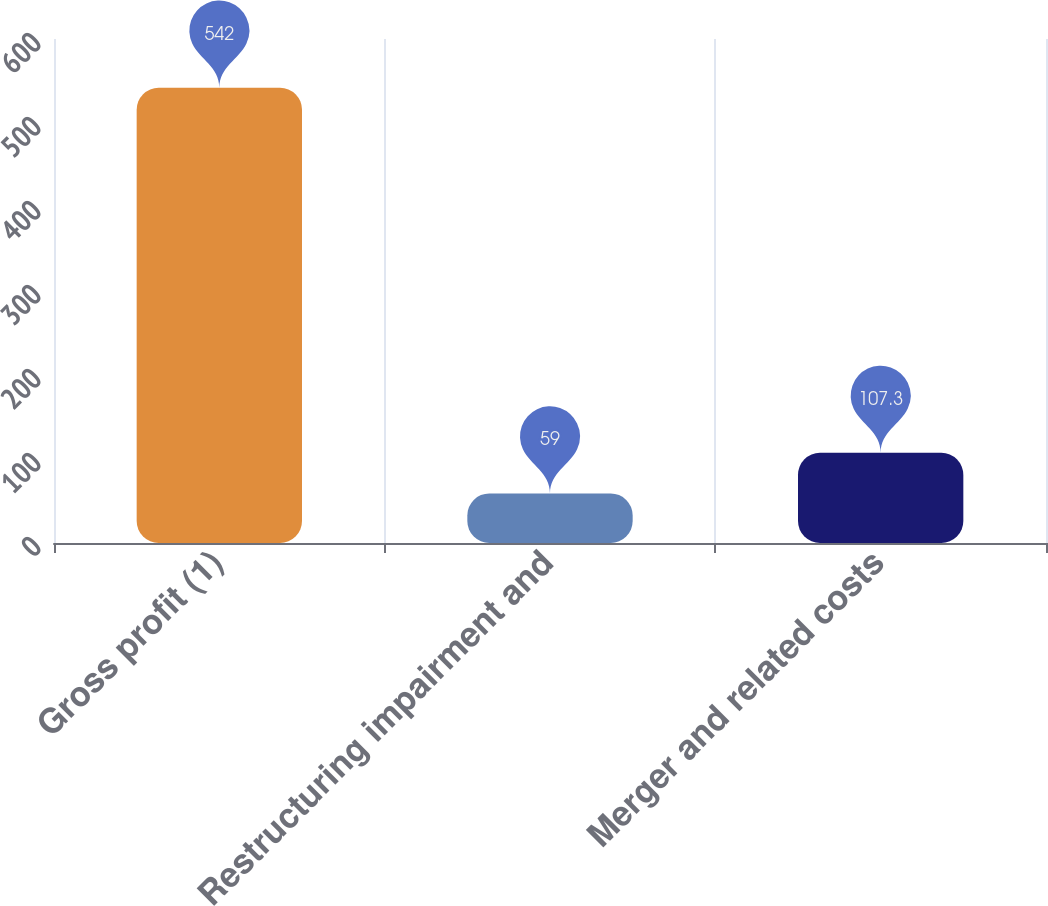Convert chart to OTSL. <chart><loc_0><loc_0><loc_500><loc_500><bar_chart><fcel>Gross profit (1)<fcel>Restructuring impairment and<fcel>Merger and related costs<nl><fcel>542<fcel>59<fcel>107.3<nl></chart> 